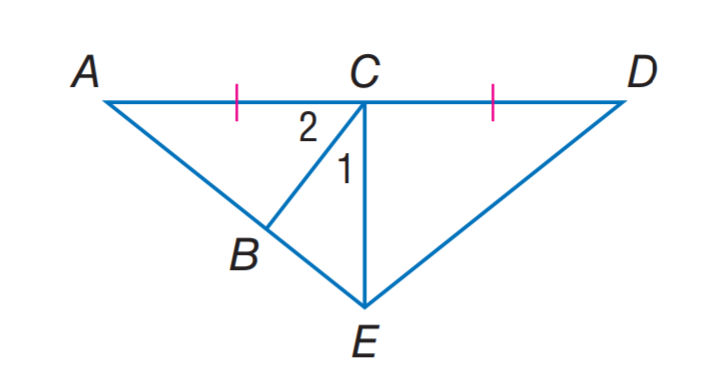Answer the mathemtical geometry problem and directly provide the correct option letter.
Question: If E C is an altitude of \triangle A E D, m \angle 1 = 2 x + 7, and m \angle 2 = 3 x + 13, find m \angle 1.
Choices: A: 25 B: 35 C: 45 D: 55 B 